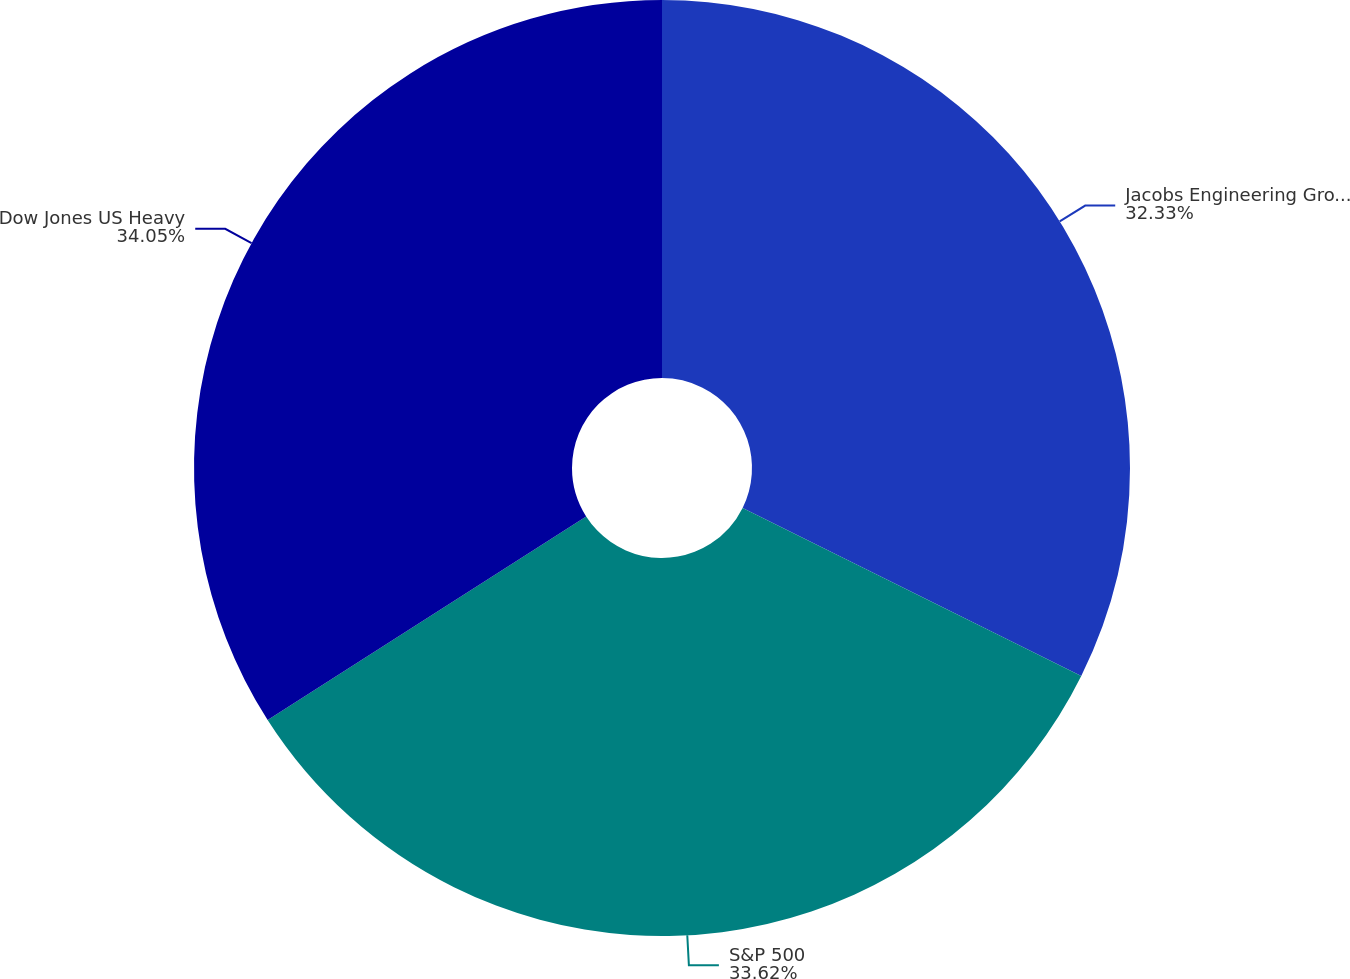<chart> <loc_0><loc_0><loc_500><loc_500><pie_chart><fcel>Jacobs Engineering Group Inc<fcel>S&P 500<fcel>Dow Jones US Heavy<nl><fcel>32.33%<fcel>33.62%<fcel>34.05%<nl></chart> 